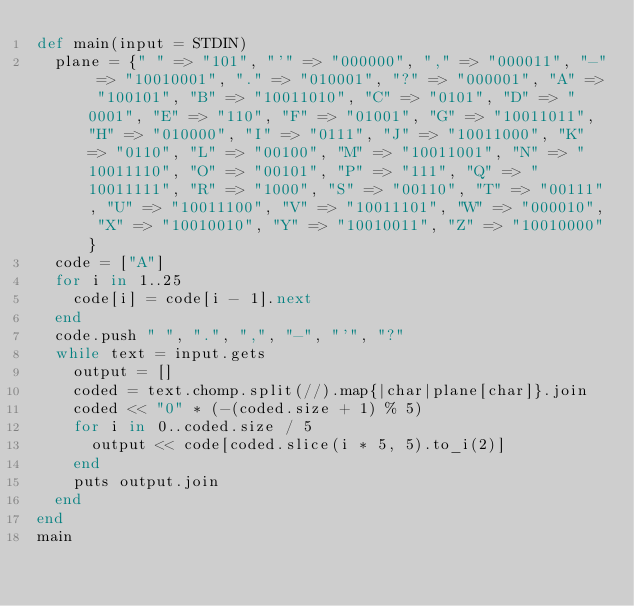Convert code to text. <code><loc_0><loc_0><loc_500><loc_500><_Ruby_>def main(input = STDIN)
  plane = {" " => "101", "'" => "000000", "," => "000011", "-" => "10010001", "." => "010001", "?" => "000001", "A" => "100101", "B" => "10011010", "C" => "0101", "D" => "0001", "E" => "110", "F" => "01001", "G" => "10011011", "H" => "010000", "I" => "0111", "J" => "10011000", "K" => "0110", "L" => "00100", "M" => "10011001", "N" => "10011110", "O" => "00101", "P" => "111", "Q" => "10011111", "R" => "1000", "S" => "00110", "T" => "00111", "U" => "10011100", "V" => "10011101", "W" => "000010", "X" => "10010010", "Y" => "10010011", "Z" => "10010000"}
  code = ["A"]
  for i in 1..25
    code[i] = code[i - 1].next
  end
  code.push " ", ".", ",", "-", "'", "?"
  while text = input.gets
    output = []
    coded = text.chomp.split(//).map{|char|plane[char]}.join
    coded << "0" * (-(coded.size + 1) % 5)
    for i in 0..coded.size / 5
      output << code[coded.slice(i * 5, 5).to_i(2)]
    end
    puts output.join
  end
end
main</code> 